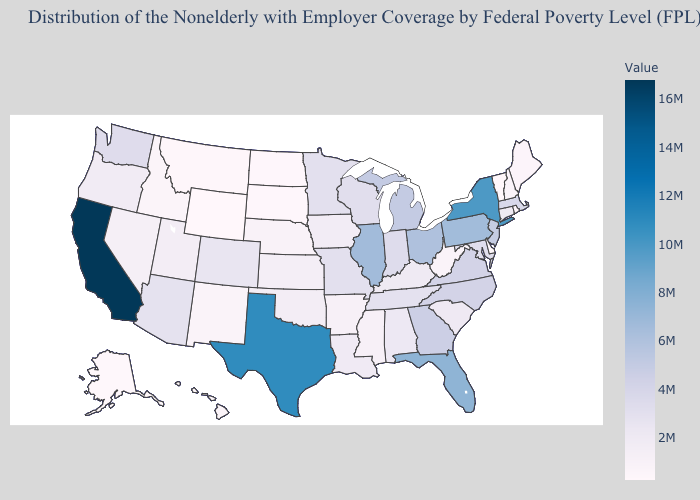Does California have the highest value in the USA?
Quick response, please. Yes. Among the states that border Iowa , which have the highest value?
Quick response, please. Illinois. Among the states that border Kentucky , does Ohio have the highest value?
Write a very short answer. No. Is the legend a continuous bar?
Short answer required. Yes. Among the states that border Louisiana , does Mississippi have the highest value?
Keep it brief. No. Does New Jersey have the lowest value in the Northeast?
Write a very short answer. No. Does the map have missing data?
Write a very short answer. No. Among the states that border Nebraska , which have the lowest value?
Short answer required. Wyoming. 